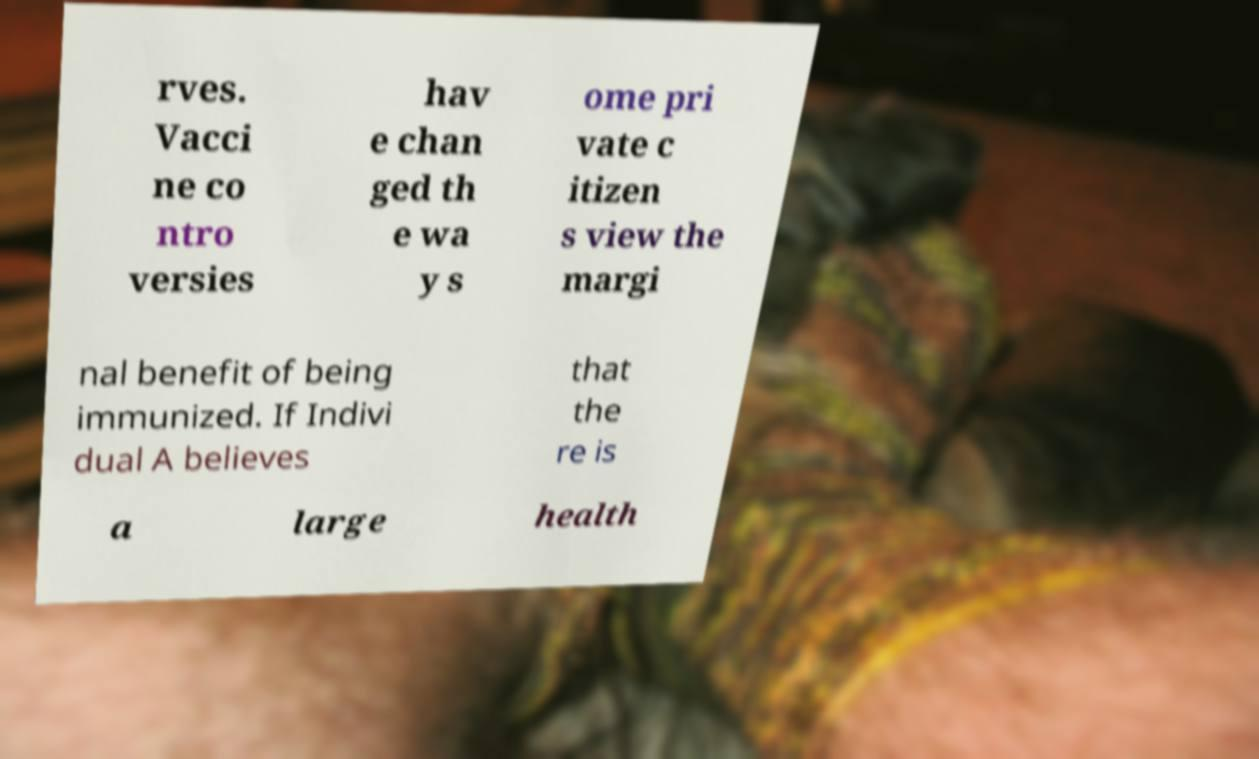For documentation purposes, I need the text within this image transcribed. Could you provide that? rves. Vacci ne co ntro versies hav e chan ged th e wa y s ome pri vate c itizen s view the margi nal benefit of being immunized. If Indivi dual A believes that the re is a large health 